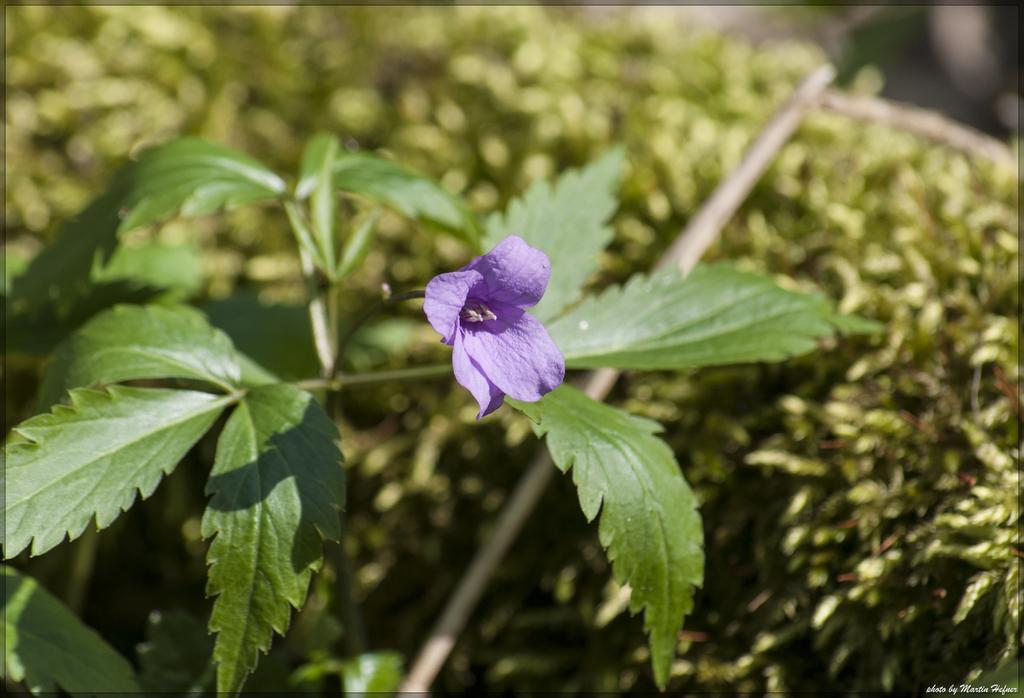What type of flower can be seen in the image? There is a violet color flower in the image. Where is the flower located? The flower is on a plant. What other object can be seen in the image? There is a stick in the image. What can be seen in the background of the image? There are plants in the background of the image. What thrill can be experienced while looking at the flower in the image? There is no mention of a thrill or any emotional experience in the image; it simply depicts a violet color flower on a plant. 